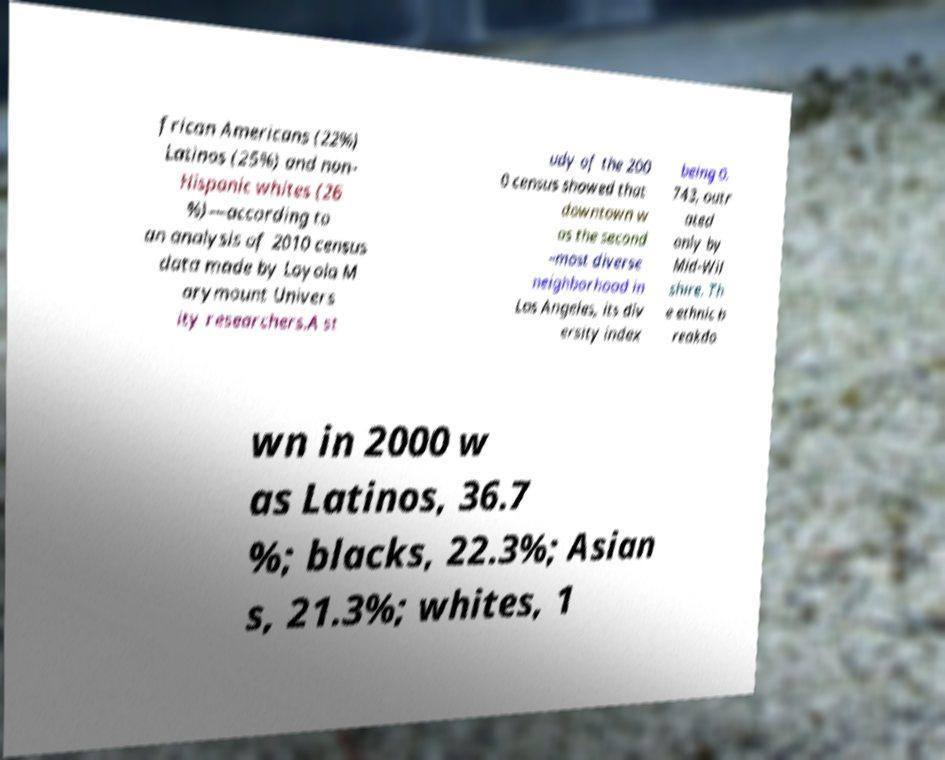Can you accurately transcribe the text from the provided image for me? frican Americans (22%) Latinos (25%) and non- Hispanic whites (26 %)—according to an analysis of 2010 census data made by Loyola M arymount Univers ity researchers.A st udy of the 200 0 census showed that downtown w as the second –most diverse neighborhood in Los Angeles, its div ersity index being 0. 743, outr ated only by Mid-Wil shire. Th e ethnic b reakdo wn in 2000 w as Latinos, 36.7 %; blacks, 22.3%; Asian s, 21.3%; whites, 1 